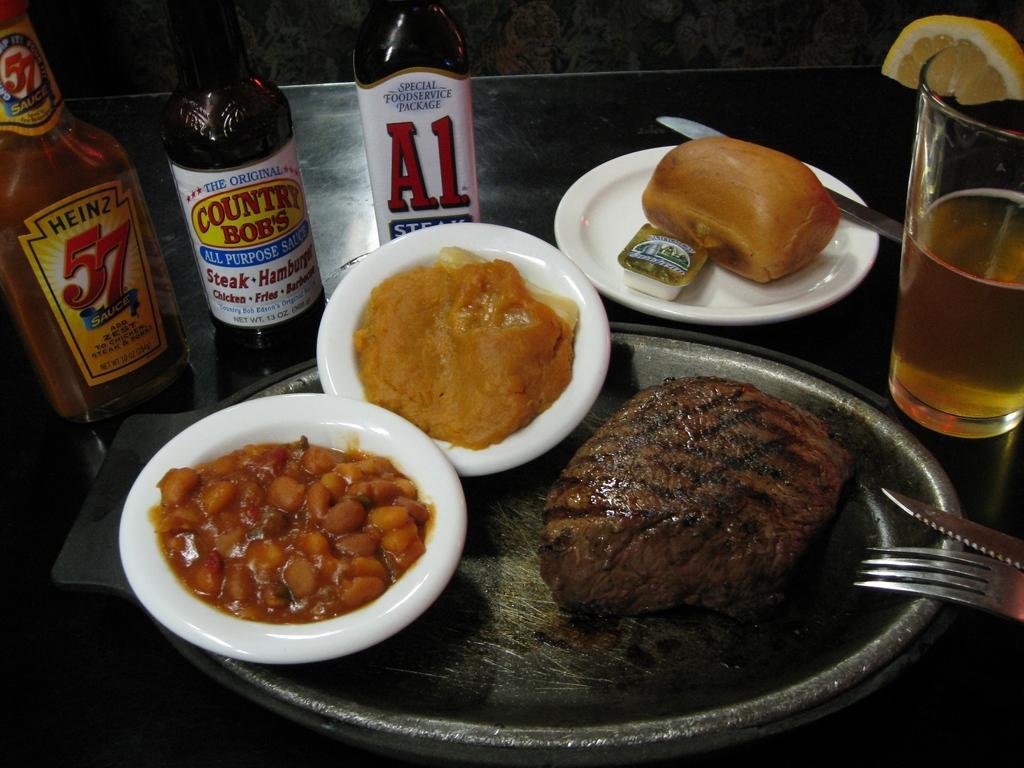Could you give a brief overview of what you see in this image? In this image there are food items on a plate. There are bottles. There is a glass with slice of lemon on it. There are knives and a fork on the table. In the background of the image there is a wall. 